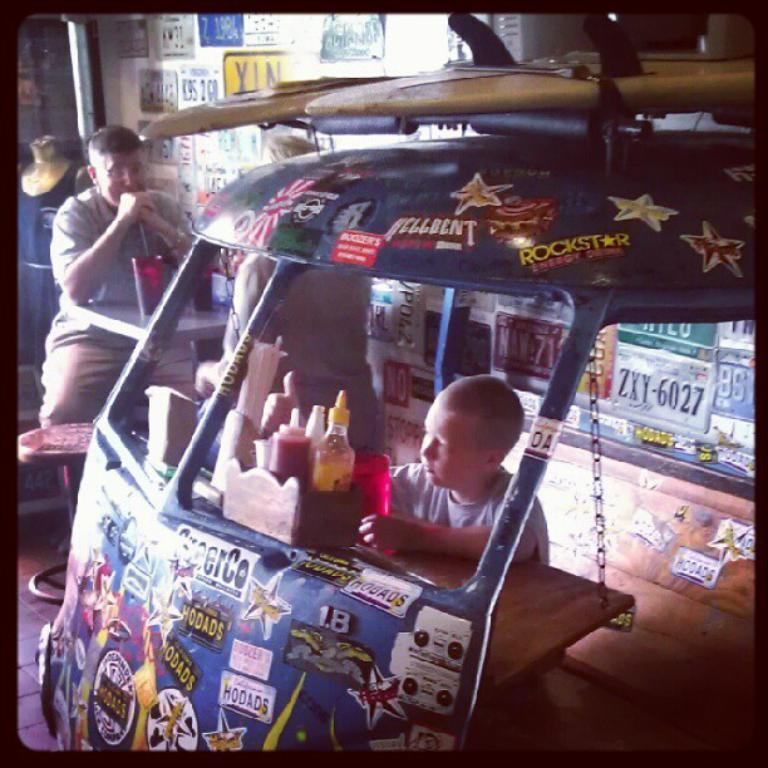Can you describe this image briefly? In this image, we can see an object. Here we can see few people, bottles, chain, some objects. Background we can see number plates and mannequin. The borders of the image, we can see black color. Here there is a table on the floor. 